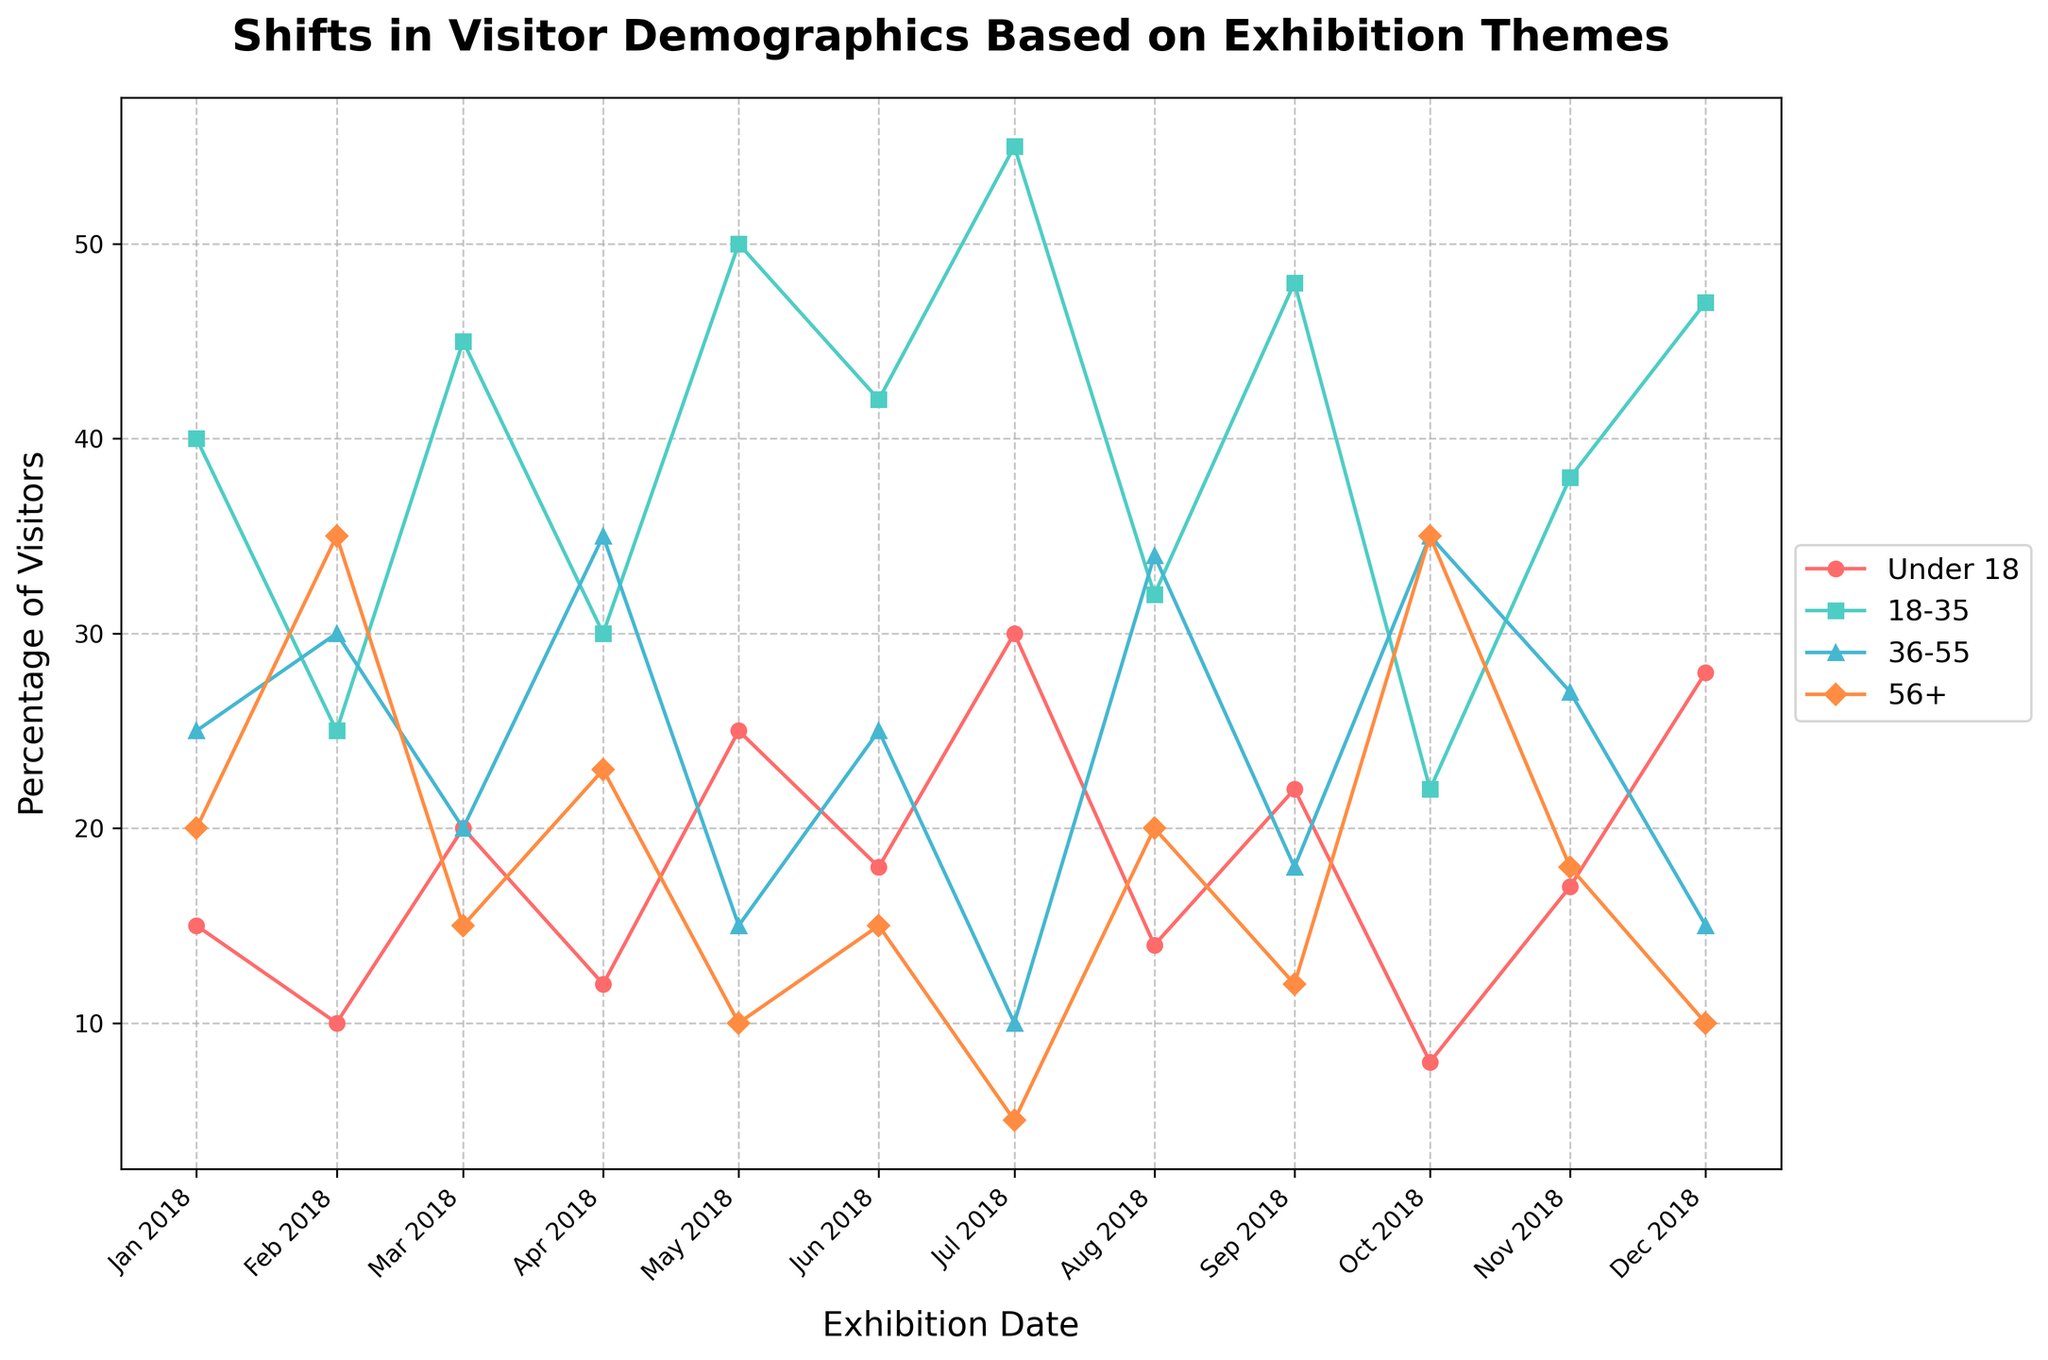what is the title of this plot? The title of the plot is the main descriptive text located at the top of the figure, which gives an overview of what the data represents. In this case, it is 'Shifts in Visitor Demographics Based on Exhibition Themes'.
Answer: Shifts in Visitor Demographics Based on Exhibition Themes What is the percentage of visitors aged 18-35 for the 'Digital Installations' exhibition? To find this information, locate the 'Digital Installations' exhibition on the x-axis and then look at the corresponding percentage for the 18-35 age group, represented by the line with square markers.
Answer: 50% Which exhibition theme had the highest percentage of under-18 visitors and what was the percentage? Look at the plot to find the peak points of the line with circles representing the 'Under 18' demographic. The highest point corresponds to 'Pop Culture Icons'.
Answer: Pop Culture Icons, 30% What are the trends for the 'Percentage 36-55' group across all exhibition themes? Follow the line with triangles representing the 'Percentage 36-55' group. Notice that it shows fluctuations with peaks at 'Classic Paintings', 'Impressionist Art', and 'World War Memorabilia'.
Answer: Fluctuates with peaks Which exhibition had the highest percentage of visitors aged 56+ and by how much? Find the peak points of the line with diamond markers, which represent the '56+' demographic. The exhibition theme at that high point is 'Historical Artifacts'.
Answer: Historical Artifacts, 35% Compare the visitor percentages of the 'Under 18' and '56+' demographics for 'Classic Paintings'. For 'Classic Paintings', identify the values along the circle-marked ('Under 18') and diamond-marked ('56+') lines. The values are 12% and 23%, respectively.
Answer: Under 18: 12%, 56+: 23% Which demographic had the largest percentage decline between two consecutive exhibitions? Compare the lines to see which had the steepest drop between any two adjacent points. The 'Under 18' line shows a notable decline from 'Pop Culture Icons' to 'Impressionist Art'.
Answer: Under 18, between Pop Culture Icons and Impressionist Art What is the trend of the 'Percentage 18-35' group across the entire year? Follow the line with squares representing the 'Percentage 18-35' group. Notice it generally rises with peaks and maintains relatively high percentages throughout the year.
Answer: Generally rising with some fluctuations Which age group had the most significant percentage variance over the 12-month period? Examine the overall range difference in each demographic line. The 'Under 18' group shows the most substantial variance, going from 8% to 30%.
Answer: Under 18 How did visitor demographics change for 'Fashion Through Ages' compared to 'Interactive Architecture’? Compare the lines' corresponding points. For 'Fashion Through Ages' the percentages are 22%, 48%, 18%, 12% respectively; for 'Interactive Architecture', the percentages are 28%, 47%, 15%, 10%.
Answer: Shifted from higher Under 18 and 56+ to higher 18-35 